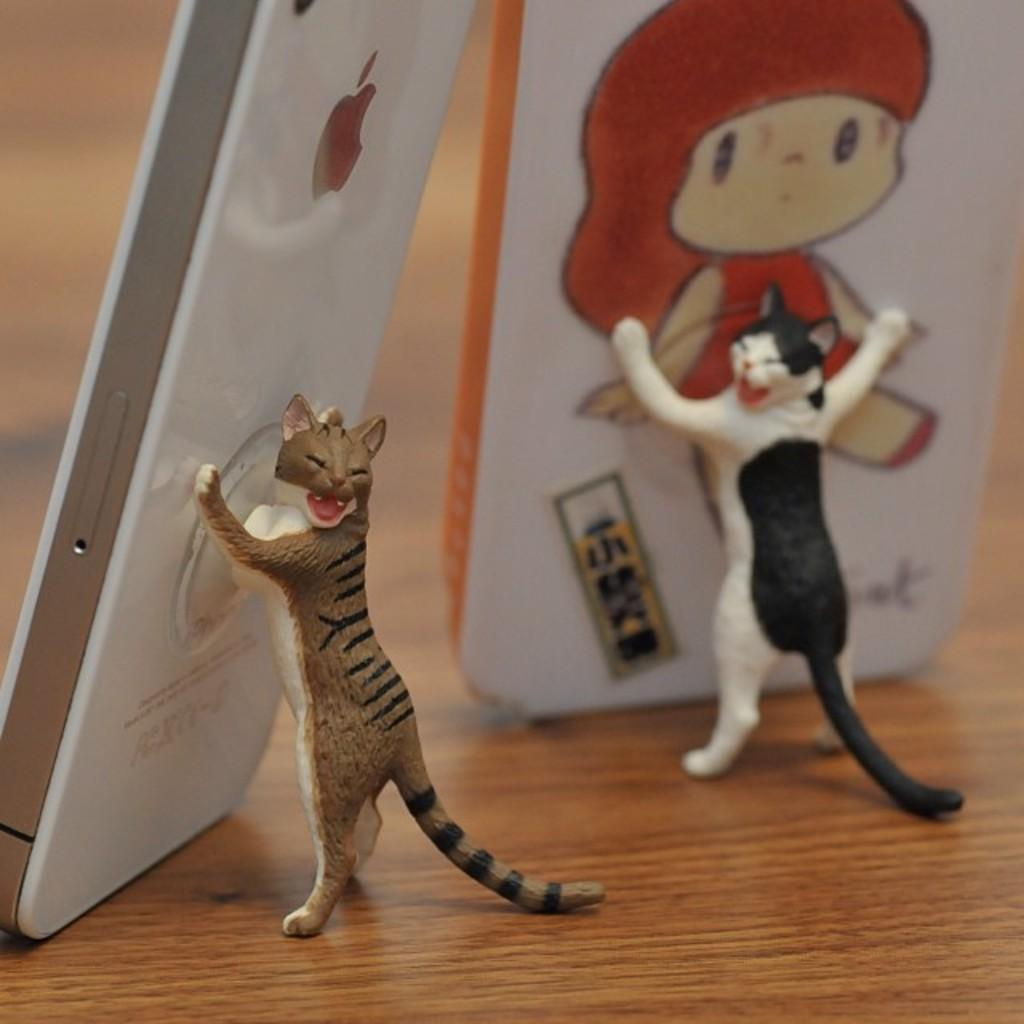What type of objects can be seen in the image? There are mobiles and mobile stands in the image. How are the mobiles and mobile stands arranged? They are arranged in a cat structure. What can be observed in the background of the image? There is a wooden texture in the background of the image. Can you tell me how many muscles are visible in the image? There are no muscles visible in the image; it features mobiles and mobile stands arranged in a cat structure. What type of map is shown in the image? There is no map present in the image. 